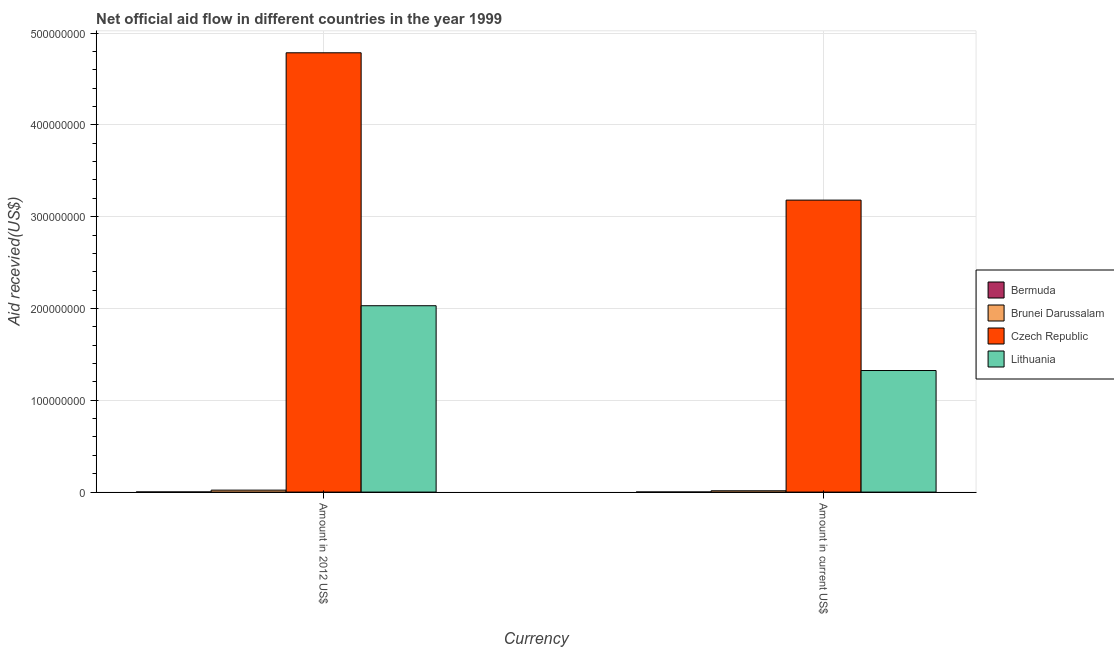How many different coloured bars are there?
Your answer should be very brief. 4. How many groups of bars are there?
Provide a succinct answer. 2. Are the number of bars per tick equal to the number of legend labels?
Ensure brevity in your answer.  Yes. How many bars are there on the 1st tick from the right?
Your answer should be compact. 4. What is the label of the 2nd group of bars from the left?
Offer a very short reply. Amount in current US$. What is the amount of aid received(expressed in us$) in Czech Republic?
Your response must be concise. 3.18e+08. Across all countries, what is the maximum amount of aid received(expressed in us$)?
Your response must be concise. 3.18e+08. Across all countries, what is the minimum amount of aid received(expressed in us$)?
Ensure brevity in your answer.  8.00e+04. In which country was the amount of aid received(expressed in us$) maximum?
Provide a succinct answer. Czech Republic. In which country was the amount of aid received(expressed in 2012 us$) minimum?
Your answer should be very brief. Bermuda. What is the total amount of aid received(expressed in 2012 us$) in the graph?
Ensure brevity in your answer.  6.84e+08. What is the difference between the amount of aid received(expressed in us$) in Lithuania and that in Bermuda?
Provide a short and direct response. 1.32e+08. What is the difference between the amount of aid received(expressed in us$) in Czech Republic and the amount of aid received(expressed in 2012 us$) in Lithuania?
Your answer should be compact. 1.15e+08. What is the average amount of aid received(expressed in us$) per country?
Give a very brief answer. 1.13e+08. What is the difference between the amount of aid received(expressed in 2012 us$) and amount of aid received(expressed in us$) in Lithuania?
Provide a succinct answer. 7.06e+07. In how many countries, is the amount of aid received(expressed in 2012 us$) greater than 160000000 US$?
Provide a short and direct response. 2. What is the ratio of the amount of aid received(expressed in 2012 us$) in Czech Republic to that in Brunei Darussalam?
Ensure brevity in your answer.  224.62. In how many countries, is the amount of aid received(expressed in us$) greater than the average amount of aid received(expressed in us$) taken over all countries?
Give a very brief answer. 2. What does the 3rd bar from the left in Amount in 2012 US$ represents?
Ensure brevity in your answer.  Czech Republic. What does the 3rd bar from the right in Amount in 2012 US$ represents?
Make the answer very short. Brunei Darussalam. How many bars are there?
Keep it short and to the point. 8. What is the difference between two consecutive major ticks on the Y-axis?
Your response must be concise. 1.00e+08. What is the title of the graph?
Make the answer very short. Net official aid flow in different countries in the year 1999. Does "Bahamas" appear as one of the legend labels in the graph?
Provide a succinct answer. No. What is the label or title of the X-axis?
Ensure brevity in your answer.  Currency. What is the label or title of the Y-axis?
Provide a succinct answer. Aid recevied(US$). What is the Aid recevied(US$) of Brunei Darussalam in Amount in 2012 US$?
Provide a succinct answer. 2.13e+06. What is the Aid recevied(US$) in Czech Republic in Amount in 2012 US$?
Your response must be concise. 4.78e+08. What is the Aid recevied(US$) of Lithuania in Amount in 2012 US$?
Your response must be concise. 2.03e+08. What is the Aid recevied(US$) of Brunei Darussalam in Amount in current US$?
Offer a very short reply. 1.43e+06. What is the Aid recevied(US$) of Czech Republic in Amount in current US$?
Make the answer very short. 3.18e+08. What is the Aid recevied(US$) of Lithuania in Amount in current US$?
Ensure brevity in your answer.  1.32e+08. Across all Currency, what is the maximum Aid recevied(US$) in Brunei Darussalam?
Give a very brief answer. 2.13e+06. Across all Currency, what is the maximum Aid recevied(US$) of Czech Republic?
Give a very brief answer. 4.78e+08. Across all Currency, what is the maximum Aid recevied(US$) of Lithuania?
Give a very brief answer. 2.03e+08. Across all Currency, what is the minimum Aid recevied(US$) in Brunei Darussalam?
Your response must be concise. 1.43e+06. Across all Currency, what is the minimum Aid recevied(US$) of Czech Republic?
Give a very brief answer. 3.18e+08. Across all Currency, what is the minimum Aid recevied(US$) in Lithuania?
Your response must be concise. 1.32e+08. What is the total Aid recevied(US$) of Bermuda in the graph?
Your answer should be compact. 2.10e+05. What is the total Aid recevied(US$) in Brunei Darussalam in the graph?
Ensure brevity in your answer.  3.56e+06. What is the total Aid recevied(US$) in Czech Republic in the graph?
Ensure brevity in your answer.  7.96e+08. What is the total Aid recevied(US$) in Lithuania in the graph?
Provide a succinct answer. 3.35e+08. What is the difference between the Aid recevied(US$) of Bermuda in Amount in 2012 US$ and that in Amount in current US$?
Offer a very short reply. 5.00e+04. What is the difference between the Aid recevied(US$) in Brunei Darussalam in Amount in 2012 US$ and that in Amount in current US$?
Your answer should be very brief. 7.00e+05. What is the difference between the Aid recevied(US$) of Czech Republic in Amount in 2012 US$ and that in Amount in current US$?
Offer a terse response. 1.60e+08. What is the difference between the Aid recevied(US$) in Lithuania in Amount in 2012 US$ and that in Amount in current US$?
Ensure brevity in your answer.  7.06e+07. What is the difference between the Aid recevied(US$) of Bermuda in Amount in 2012 US$ and the Aid recevied(US$) of Brunei Darussalam in Amount in current US$?
Ensure brevity in your answer.  -1.30e+06. What is the difference between the Aid recevied(US$) in Bermuda in Amount in 2012 US$ and the Aid recevied(US$) in Czech Republic in Amount in current US$?
Your response must be concise. -3.18e+08. What is the difference between the Aid recevied(US$) of Bermuda in Amount in 2012 US$ and the Aid recevied(US$) of Lithuania in Amount in current US$?
Your response must be concise. -1.32e+08. What is the difference between the Aid recevied(US$) in Brunei Darussalam in Amount in 2012 US$ and the Aid recevied(US$) in Czech Republic in Amount in current US$?
Offer a terse response. -3.16e+08. What is the difference between the Aid recevied(US$) of Brunei Darussalam in Amount in 2012 US$ and the Aid recevied(US$) of Lithuania in Amount in current US$?
Keep it short and to the point. -1.30e+08. What is the difference between the Aid recevied(US$) in Czech Republic in Amount in 2012 US$ and the Aid recevied(US$) in Lithuania in Amount in current US$?
Provide a short and direct response. 3.46e+08. What is the average Aid recevied(US$) in Bermuda per Currency?
Provide a succinct answer. 1.05e+05. What is the average Aid recevied(US$) in Brunei Darussalam per Currency?
Keep it short and to the point. 1.78e+06. What is the average Aid recevied(US$) in Czech Republic per Currency?
Ensure brevity in your answer.  3.98e+08. What is the average Aid recevied(US$) of Lithuania per Currency?
Your answer should be very brief. 1.68e+08. What is the difference between the Aid recevied(US$) in Bermuda and Aid recevied(US$) in Czech Republic in Amount in 2012 US$?
Make the answer very short. -4.78e+08. What is the difference between the Aid recevied(US$) of Bermuda and Aid recevied(US$) of Lithuania in Amount in 2012 US$?
Ensure brevity in your answer.  -2.03e+08. What is the difference between the Aid recevied(US$) in Brunei Darussalam and Aid recevied(US$) in Czech Republic in Amount in 2012 US$?
Provide a short and direct response. -4.76e+08. What is the difference between the Aid recevied(US$) in Brunei Darussalam and Aid recevied(US$) in Lithuania in Amount in 2012 US$?
Offer a terse response. -2.01e+08. What is the difference between the Aid recevied(US$) of Czech Republic and Aid recevied(US$) of Lithuania in Amount in 2012 US$?
Offer a terse response. 2.75e+08. What is the difference between the Aid recevied(US$) in Bermuda and Aid recevied(US$) in Brunei Darussalam in Amount in current US$?
Your answer should be compact. -1.35e+06. What is the difference between the Aid recevied(US$) in Bermuda and Aid recevied(US$) in Czech Republic in Amount in current US$?
Make the answer very short. -3.18e+08. What is the difference between the Aid recevied(US$) in Bermuda and Aid recevied(US$) in Lithuania in Amount in current US$?
Make the answer very short. -1.32e+08. What is the difference between the Aid recevied(US$) in Brunei Darussalam and Aid recevied(US$) in Czech Republic in Amount in current US$?
Provide a succinct answer. -3.17e+08. What is the difference between the Aid recevied(US$) in Brunei Darussalam and Aid recevied(US$) in Lithuania in Amount in current US$?
Keep it short and to the point. -1.31e+08. What is the difference between the Aid recevied(US$) in Czech Republic and Aid recevied(US$) in Lithuania in Amount in current US$?
Offer a very short reply. 1.86e+08. What is the ratio of the Aid recevied(US$) of Bermuda in Amount in 2012 US$ to that in Amount in current US$?
Ensure brevity in your answer.  1.62. What is the ratio of the Aid recevied(US$) of Brunei Darussalam in Amount in 2012 US$ to that in Amount in current US$?
Your answer should be compact. 1.49. What is the ratio of the Aid recevied(US$) of Czech Republic in Amount in 2012 US$ to that in Amount in current US$?
Offer a very short reply. 1.5. What is the ratio of the Aid recevied(US$) of Lithuania in Amount in 2012 US$ to that in Amount in current US$?
Make the answer very short. 1.53. What is the difference between the highest and the second highest Aid recevied(US$) of Brunei Darussalam?
Ensure brevity in your answer.  7.00e+05. What is the difference between the highest and the second highest Aid recevied(US$) of Czech Republic?
Keep it short and to the point. 1.60e+08. What is the difference between the highest and the second highest Aid recevied(US$) of Lithuania?
Make the answer very short. 7.06e+07. What is the difference between the highest and the lowest Aid recevied(US$) in Brunei Darussalam?
Give a very brief answer. 7.00e+05. What is the difference between the highest and the lowest Aid recevied(US$) in Czech Republic?
Provide a short and direct response. 1.60e+08. What is the difference between the highest and the lowest Aid recevied(US$) in Lithuania?
Make the answer very short. 7.06e+07. 